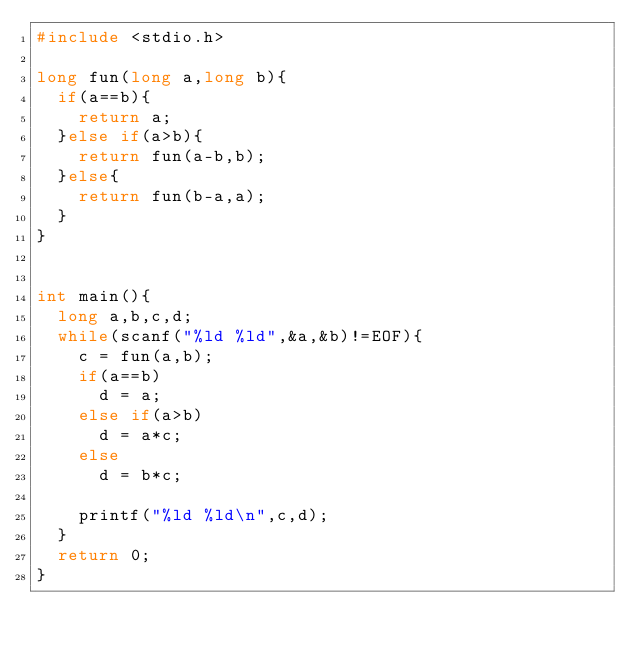<code> <loc_0><loc_0><loc_500><loc_500><_C_>#include <stdio.h>

long fun(long a,long b){
	if(a==b){
		return a;
	}else if(a>b){
		return fun(a-b,b);
	}else{
		return fun(b-a,a);
	}
}
	

int main(){
	long a,b,c,d;
	while(scanf("%ld %ld",&a,&b)!=EOF){
		c = fun(a,b);
		if(a==b)
			d = a;
		else if(a>b)
			d = a*c;
		else
			d = b*c;

		printf("%ld %ld\n",c,d);
	}
	return 0;
}</code> 